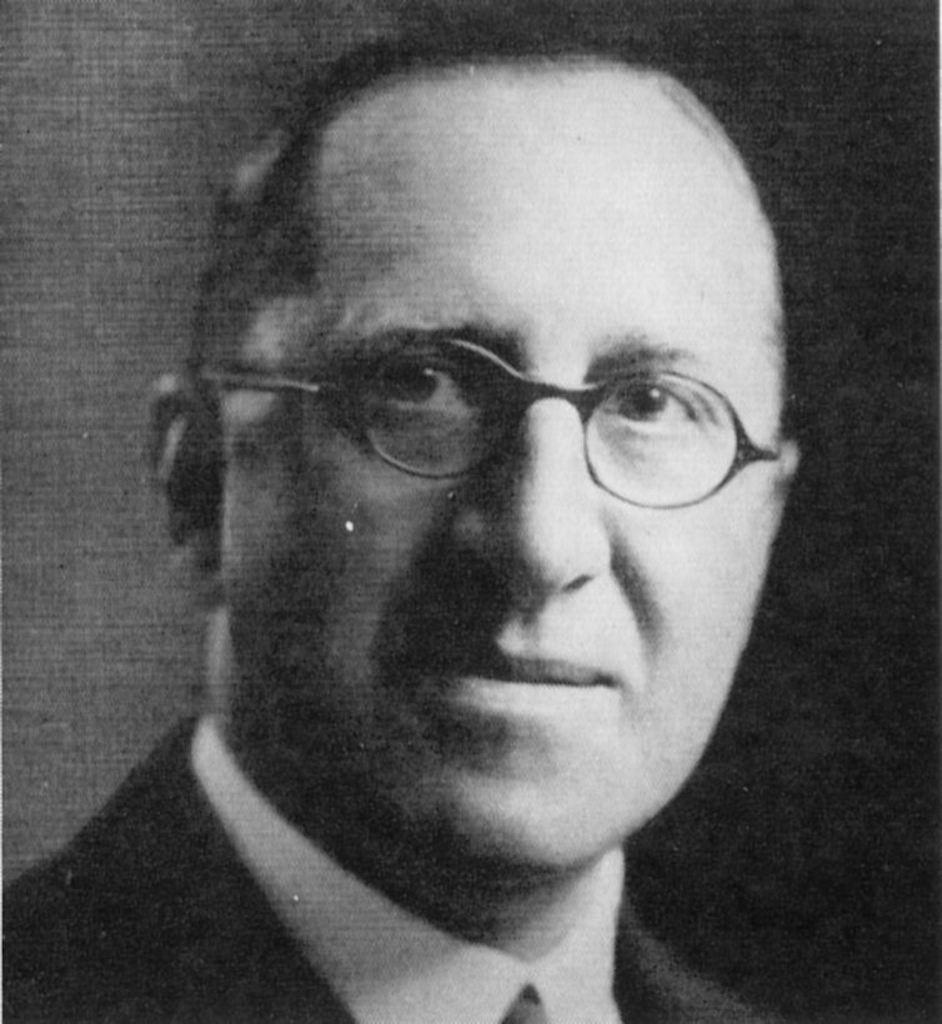What is present in the image? There is a person in the image. Can you describe the person's appearance? The person is wearing spectacles. What is the color scheme of the image? The image is black and white. What type of oven can be seen in the image? There is no oven present in the image. What color is the mint in the image? There is no mint present in the image. 